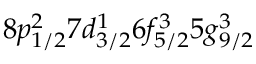<formula> <loc_0><loc_0><loc_500><loc_500>8 p _ { 1 / 2 } ^ { 2 } 7 d _ { 3 / 2 } ^ { 1 } 6 f _ { 5 / 2 } ^ { 3 } 5 g _ { 9 / 2 } ^ { 3 }</formula> 